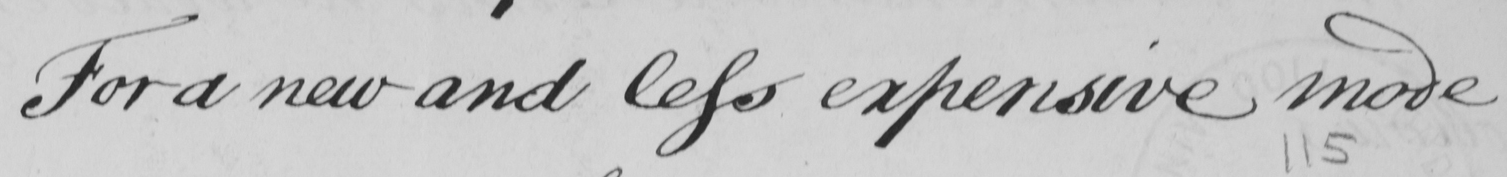Can you read and transcribe this handwriting? For a new and less expensive mode 